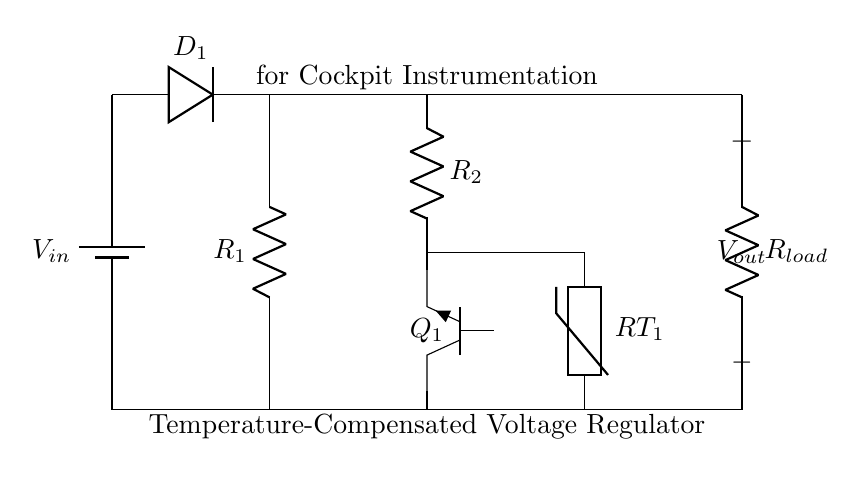What is the purpose of the Zener diode in this circuit? The Zener diode is used to provide a stable reference voltage in the regulator circuit, ensuring that the output voltage remains constant despite variations in the input voltage or load conditions.
Answer: Stable reference voltage What component is used for temperature compensation? The circuit includes a thermistor, which adjusts the voltage reference based on temperature changes, ensuring consistent performance despite temperature fluctuations.
Answer: Thermistor What type of transistor is utilized in this circuit? The diagram shows an NPN transistor, indicated by the label on the component. This allows current flow from collector to emitter when a sufficient base current is applied.
Answer: NPN What is the role of the resistor labeled R1? Resistor R1 limits the current passing through the Zener diode, preventing it from being damaged due to excessive current flow while allowing it to maintain its reference voltage.
Answer: Current limitation How many resistors are present in this circuit? The circuit contains three resistors: R1, R2, and Rload, each serving different roles in the functionality of the voltage regulator.
Answer: Three resistors What does the output voltage depend on in this regulator circuit? The output voltage is influenced by the Zener diode's voltage drop and the load resistance, which are key factors in determining the output stability under varying conditions.
Answer: Zener diode's voltage drop and load resistance 